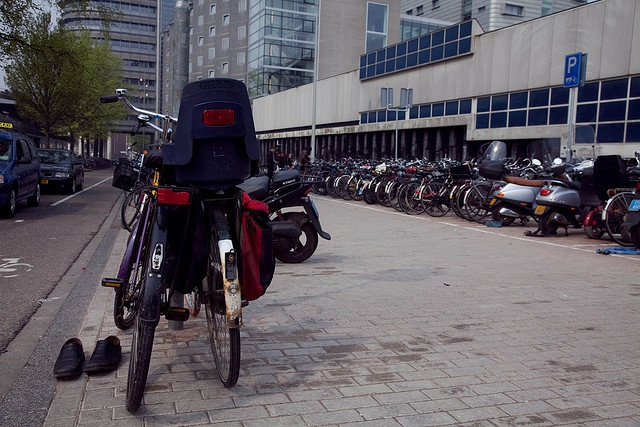Describe the objects in this image and their specific colors. I can see bicycle in black, gray, darkgray, and maroon tones, bicycle in black, gray, and maroon tones, bicycle in black, gray, and darkgray tones, motorcycle in black, gray, and darkgray tones, and backpack in black, maroon, brown, and darkgray tones in this image. 